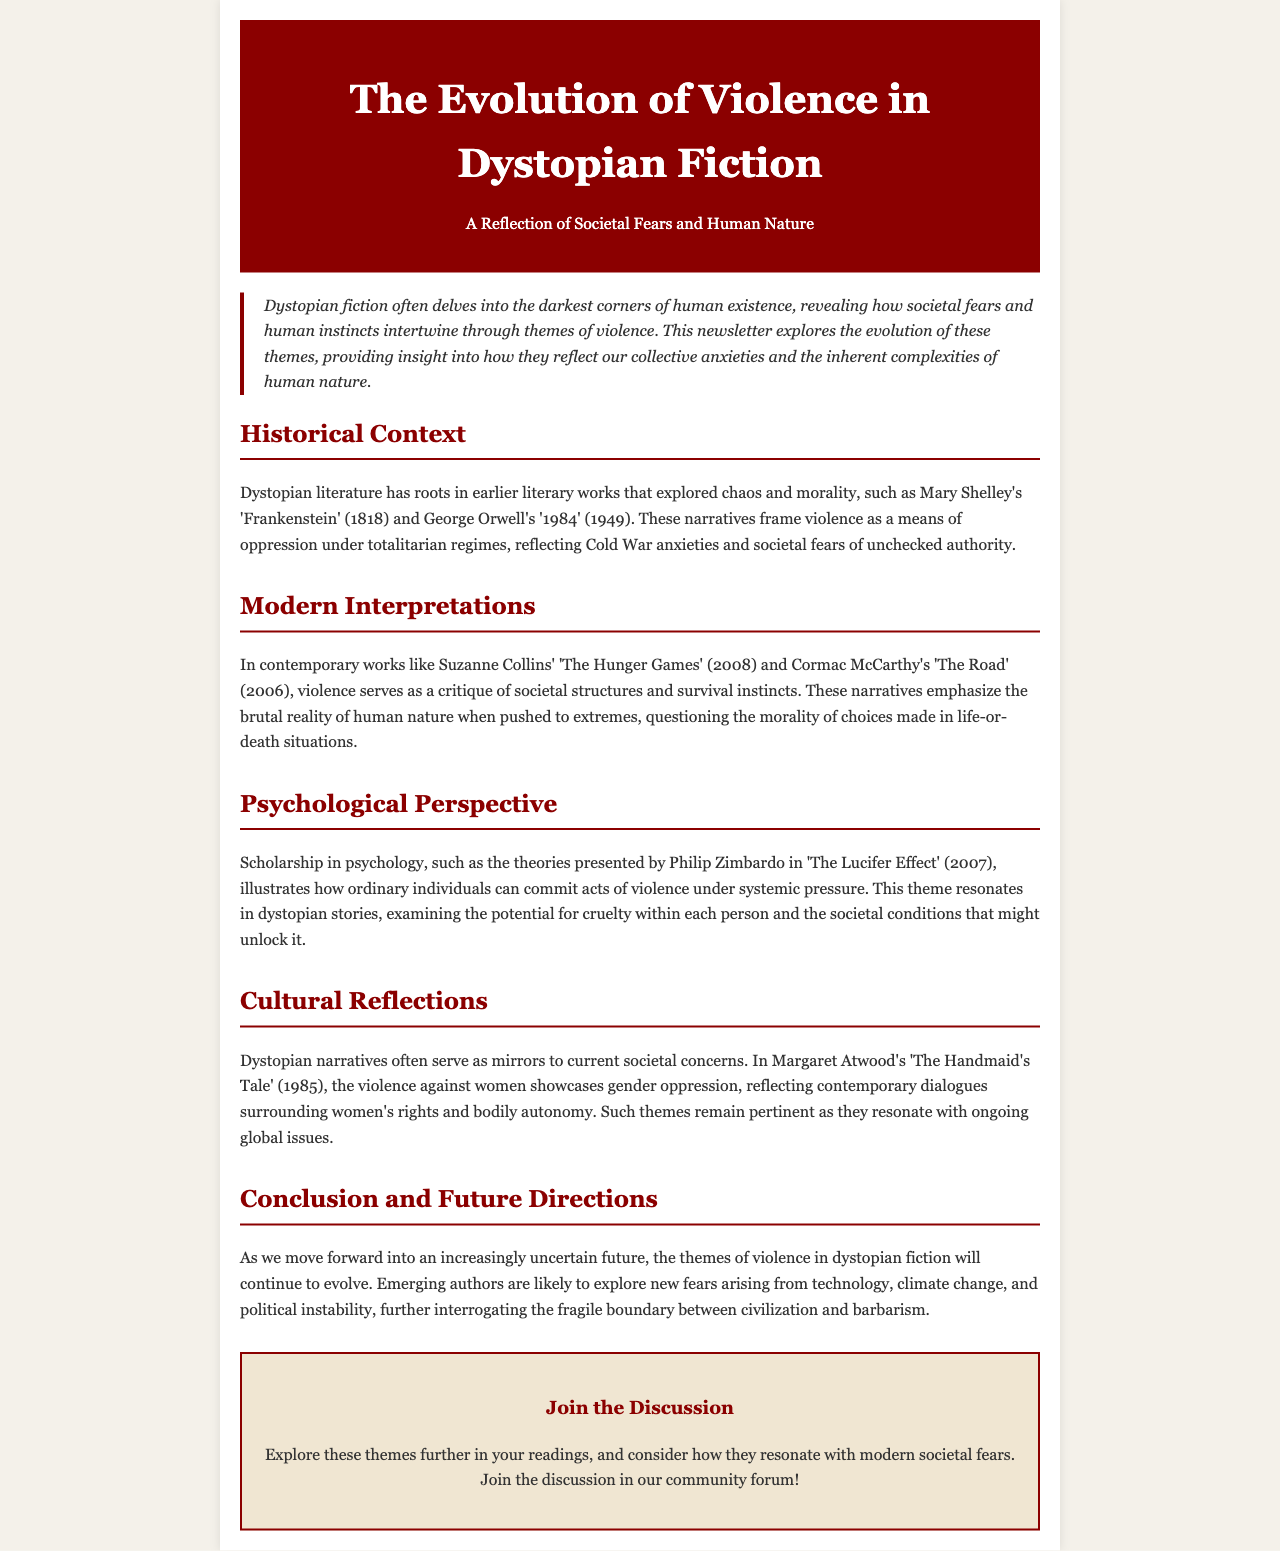What is the title of the newsletter? The title is the main heading found in the header section of the document, which highlights the focus of the newsletter.
Answer: The Evolution of Violence in Dystopian Fiction Who is one author mentioned in the Historical Context section? This question refers to the literary figures discussed in the Historical Context section, which provides examples of early dystopian works.
Answer: Mary Shelley What year was 'The Road' published? The date is specified within the Modern Interpretations section, listing the publication years of contemporary dystopian works.
Answer: 2006 What psychological theory is referenced in the Psychological Perspective section? This question asks for the name of the theory mentioned that relates to violence under systemic pressure, providing context for the themes explored in dystopian fiction.
Answer: The Lucifer Effect Which character or concept is highlighted in 'The Handmaid's Tale'? This question seeks specific information about the thematic elements relevant to contemporary societal issues as mentioned in the Cultural Reflections section.
Answer: Violence against women What genre is primarily discussed in the newsletter? The genre encompasses the main subject matter, focusing on narratives that explore darker aspects of human nature.
Answer: Dystopian fiction What societal issue does the newsletter suggest will influence future themes in dystopian fiction? This question asks for a trend or concern inferred from the concluding remarks discussing future directions in the genre.
Answer: Technology How do themes of violence relate to human nature according to the newsletter? This question probes the philosophical inquiry regarding the connection made in the document between violence and intrinsic human behavior.
Answer: Complexities 